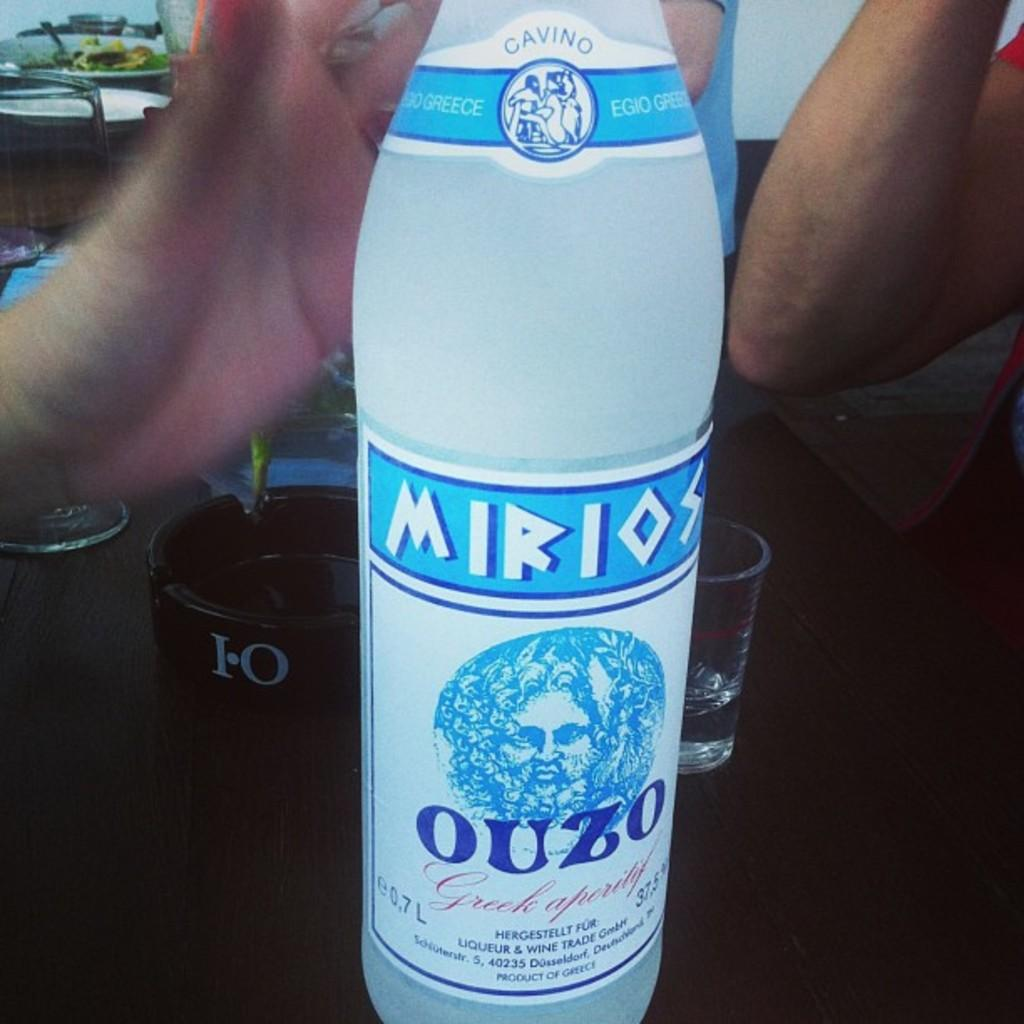<image>
Provide a brief description of the given image. Bottle of Mirios Ouzo a product of Greece sitting in front of an ash tray that has I-O on it. 